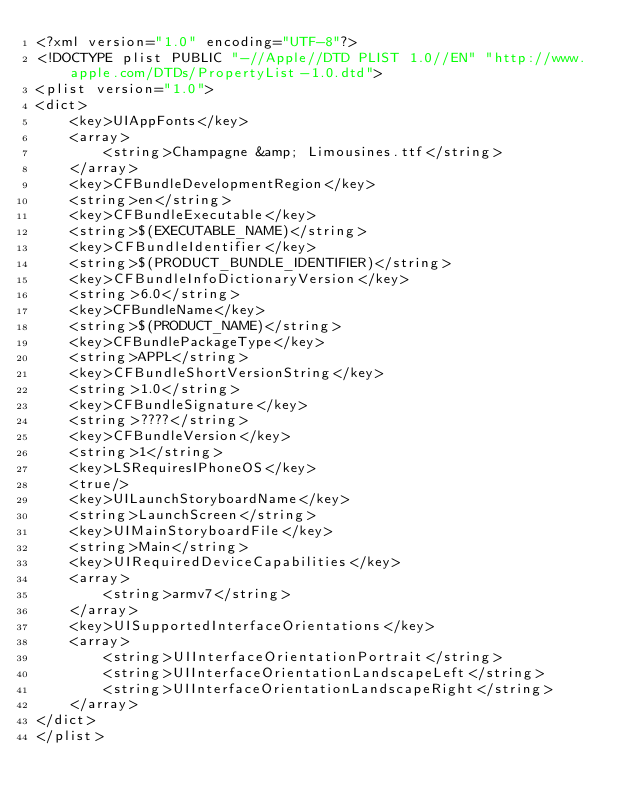<code> <loc_0><loc_0><loc_500><loc_500><_XML_><?xml version="1.0" encoding="UTF-8"?>
<!DOCTYPE plist PUBLIC "-//Apple//DTD PLIST 1.0//EN" "http://www.apple.com/DTDs/PropertyList-1.0.dtd">
<plist version="1.0">
<dict>
	<key>UIAppFonts</key>
	<array>
		<string>Champagne &amp; Limousines.ttf</string>
	</array>
	<key>CFBundleDevelopmentRegion</key>
	<string>en</string>
	<key>CFBundleExecutable</key>
	<string>$(EXECUTABLE_NAME)</string>
	<key>CFBundleIdentifier</key>
	<string>$(PRODUCT_BUNDLE_IDENTIFIER)</string>
	<key>CFBundleInfoDictionaryVersion</key>
	<string>6.0</string>
	<key>CFBundleName</key>
	<string>$(PRODUCT_NAME)</string>
	<key>CFBundlePackageType</key>
	<string>APPL</string>
	<key>CFBundleShortVersionString</key>
	<string>1.0</string>
	<key>CFBundleSignature</key>
	<string>????</string>
	<key>CFBundleVersion</key>
	<string>1</string>
	<key>LSRequiresIPhoneOS</key>
	<true/>
	<key>UILaunchStoryboardName</key>
	<string>LaunchScreen</string>
	<key>UIMainStoryboardFile</key>
	<string>Main</string>
	<key>UIRequiredDeviceCapabilities</key>
	<array>
		<string>armv7</string>
	</array>
	<key>UISupportedInterfaceOrientations</key>
	<array>
		<string>UIInterfaceOrientationPortrait</string>
		<string>UIInterfaceOrientationLandscapeLeft</string>
		<string>UIInterfaceOrientationLandscapeRight</string>
	</array>
</dict>
</plist>
</code> 